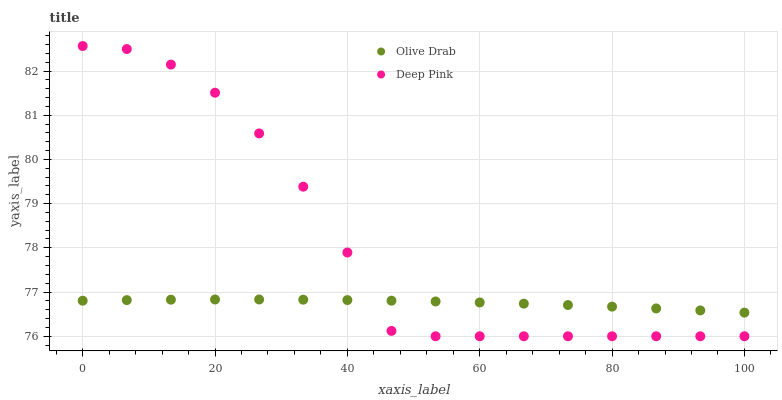Does Olive Drab have the minimum area under the curve?
Answer yes or no. Yes. Does Deep Pink have the maximum area under the curve?
Answer yes or no. Yes. Does Olive Drab have the maximum area under the curve?
Answer yes or no. No. Is Olive Drab the smoothest?
Answer yes or no. Yes. Is Deep Pink the roughest?
Answer yes or no. Yes. Is Olive Drab the roughest?
Answer yes or no. No. Does Deep Pink have the lowest value?
Answer yes or no. Yes. Does Olive Drab have the lowest value?
Answer yes or no. No. Does Deep Pink have the highest value?
Answer yes or no. Yes. Does Olive Drab have the highest value?
Answer yes or no. No. Does Deep Pink intersect Olive Drab?
Answer yes or no. Yes. Is Deep Pink less than Olive Drab?
Answer yes or no. No. Is Deep Pink greater than Olive Drab?
Answer yes or no. No. 